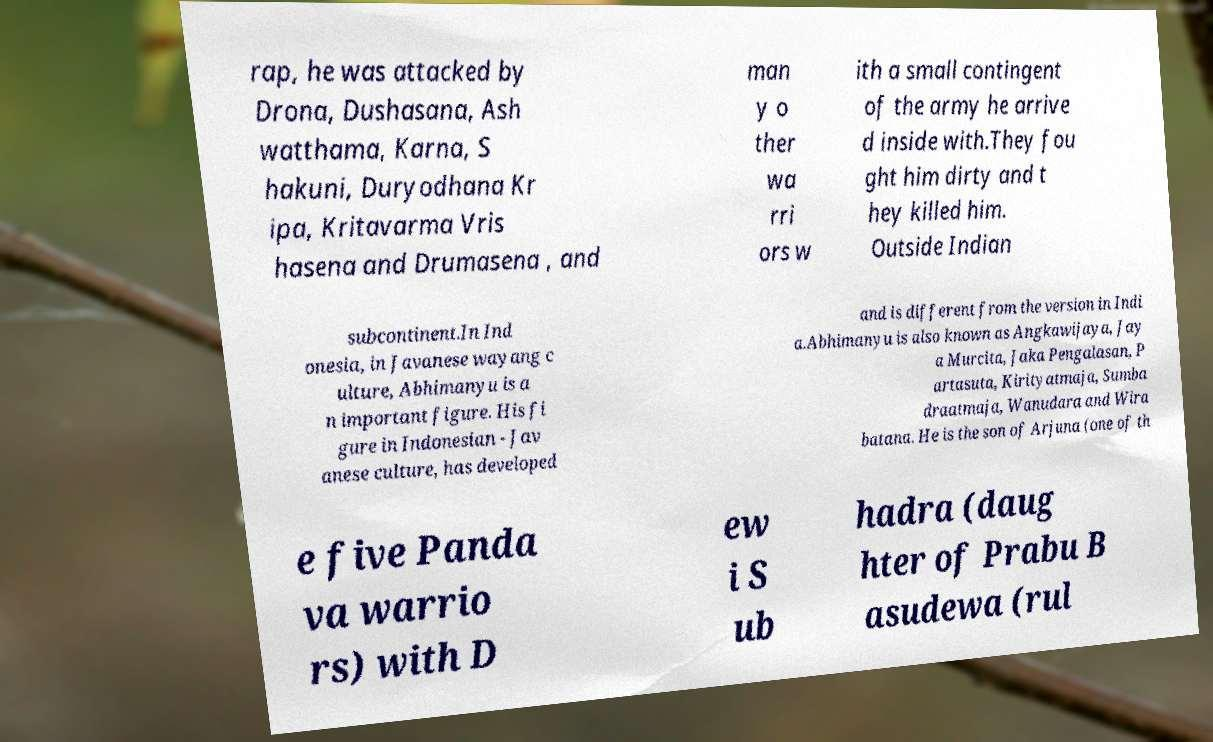I need the written content from this picture converted into text. Can you do that? rap, he was attacked by Drona, Dushasana, Ash watthama, Karna, S hakuni, Duryodhana Kr ipa, Kritavarma Vris hasena and Drumasena , and man y o ther wa rri ors w ith a small contingent of the army he arrive d inside with.They fou ght him dirty and t hey killed him. Outside Indian subcontinent.In Ind onesia, in Javanese wayang c ulture, Abhimanyu is a n important figure. His fi gure in Indonesian - Jav anese culture, has developed and is different from the version in Indi a.Abhimanyu is also known as Angkawijaya, Jay a Murcita, Jaka Pengalasan, P artasuta, Kirityatmaja, Sumba draatmaja, Wanudara and Wira batana. He is the son of Arjuna (one of th e five Panda va warrio rs) with D ew i S ub hadra (daug hter of Prabu B asudewa (rul 